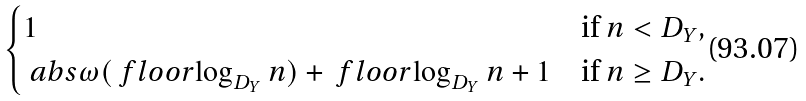Convert formula to latex. <formula><loc_0><loc_0><loc_500><loc_500>\begin{cases} 1 & \text {if } n < D _ { Y } , \\ \ a b s { \omega ( \ f l o o r { \log _ { D _ { Y } } n } ) } + \ f l o o r { \log _ { D _ { Y } } n } + 1 & \text {if } n \geq D _ { Y } . \end{cases}</formula> 